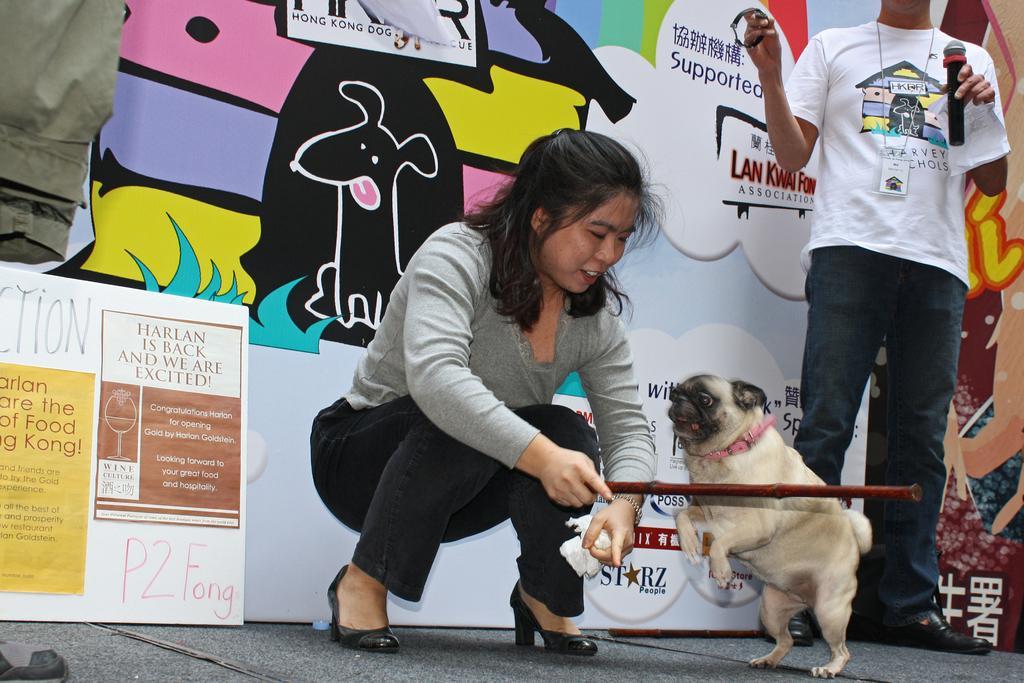How would you summarize this image in a sentence or two? In this picture we can see woman holding stick in her hand and in front of her we can see dog jumping on it and beside to her we can see man holding mic and watch in his hands and in background we can see wall with banner. 